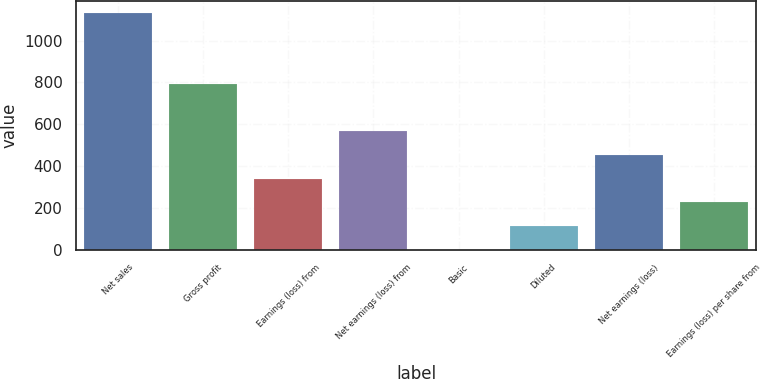Convert chart to OTSL. <chart><loc_0><loc_0><loc_500><loc_500><bar_chart><fcel>Net sales<fcel>Gross profit<fcel>Earnings (loss) from<fcel>Net earnings (loss) from<fcel>Basic<fcel>Diluted<fcel>Net earnings (loss)<fcel>Earnings (loss) per share from<nl><fcel>1132.2<fcel>792.62<fcel>339.86<fcel>566.24<fcel>0.29<fcel>113.48<fcel>453.05<fcel>226.67<nl></chart> 